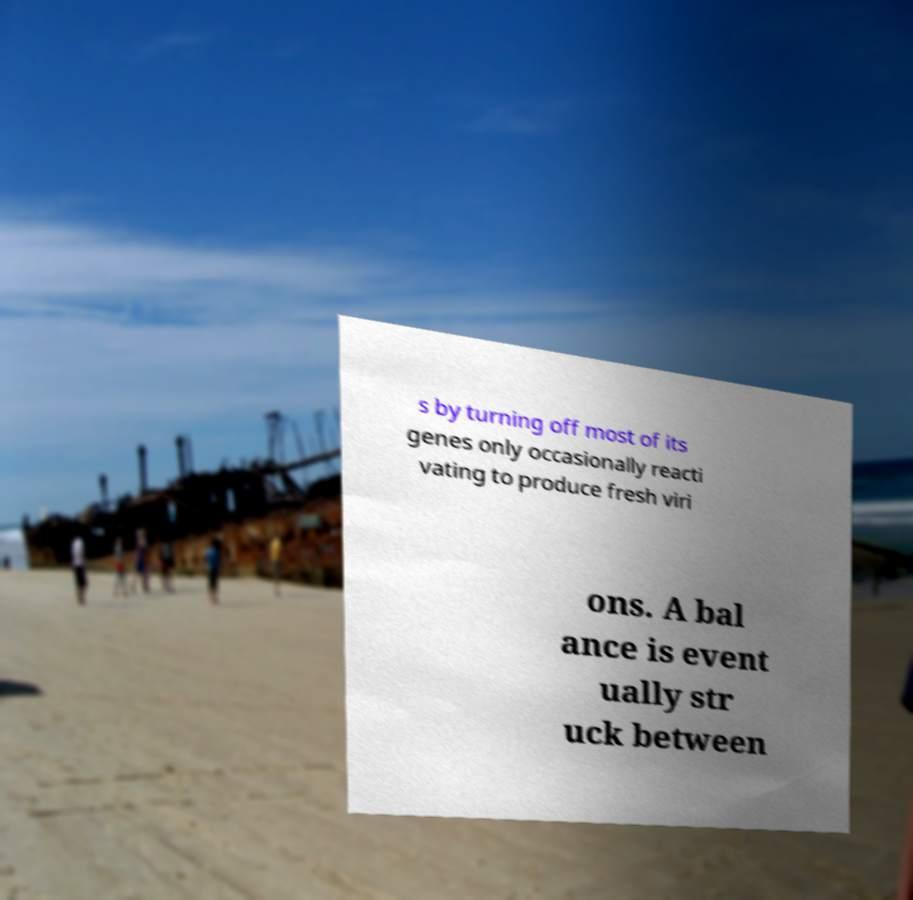Could you extract and type out the text from this image? s by turning off most of its genes only occasionally reacti vating to produce fresh viri ons. A bal ance is event ually str uck between 